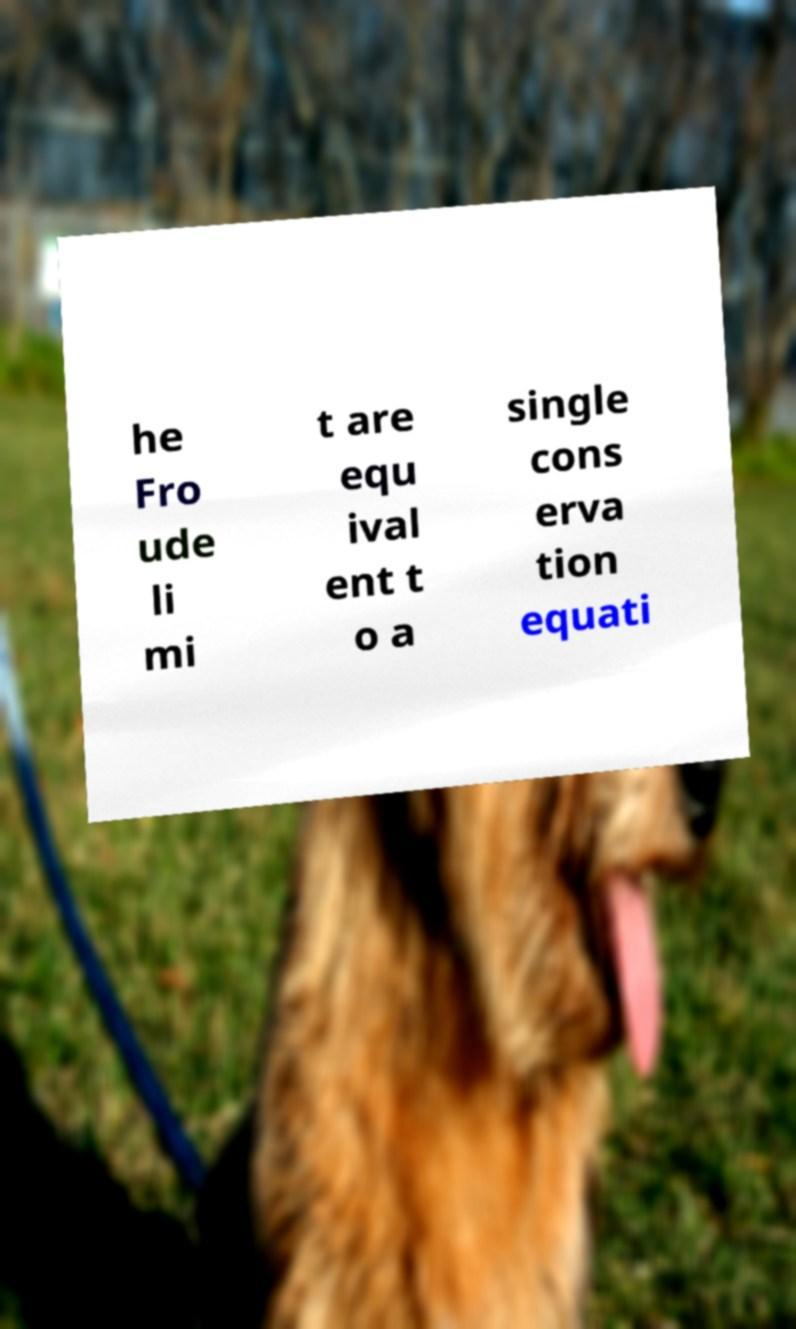There's text embedded in this image that I need extracted. Can you transcribe it verbatim? he Fro ude li mi t are equ ival ent t o a single cons erva tion equati 